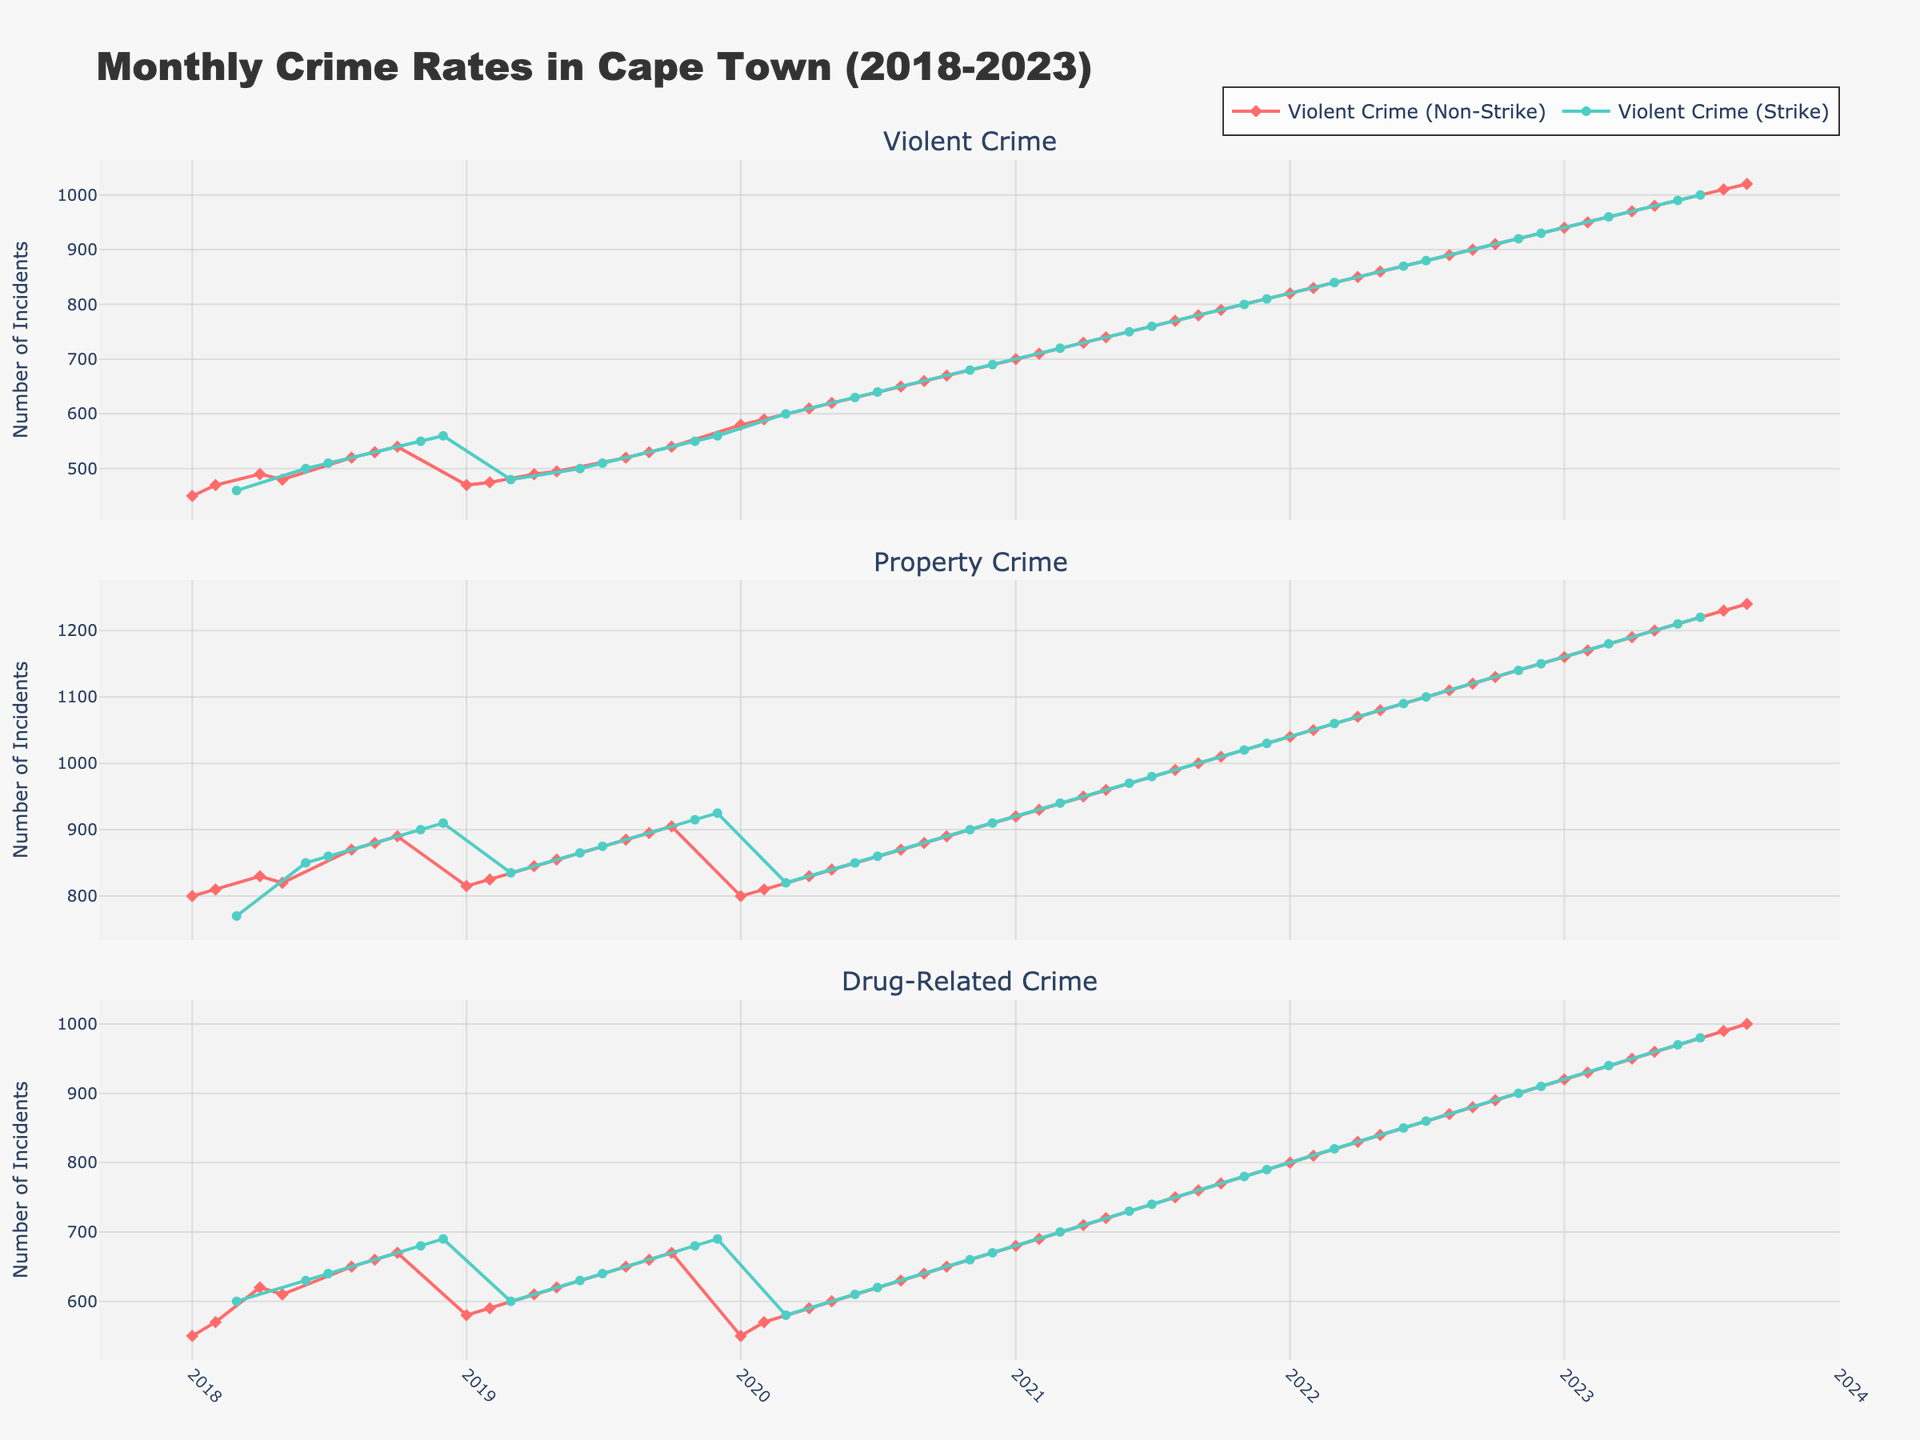How does the violent crime rate during strike periods compare to non-strike periods? To compare, look at the violent crime trend lines for periods marked as "Strike" and "Non-Strike," identified by the different colors in the plot. Examine their heights and patterns over time.
Answer: Higher during strikes What is the general trend of property crime over the five years? Observe the property crime line. Assess whether it increases, decreases, or remains constant over the period from 2018 to 2023.
Answer: Increasing Are drug-related crimes more frequent in strike periods or non-strike periods? Compare the heights and markers of drug-related crime lines for periods labeled as 'Yes' and 'No'. The frequency can be inferred from higher values.
Answer: More frequent in non-strike periods Which year had the highest peak in violent crime? Find the highest point in the violent crime subplot and match it to the corresponding year on the x-axis below the point.
Answer: 2023 What is the most noticeable difference between strike and non-strike periods for property crimes? Look for variations in the property crime line's behavior during periods marked 'Yes' and 'No'. Note the changes in the pattern or level.
Answer: Non-strike periods generally have lower property crimes Which type of crime shows the least variation between strike and non-strike periods? Assess the variation in plot lines between strike and non-strike periods for each crime type. The one with the smallest difference is the answer.
Answer: Property Crime By how much did violent crime increase from January 2018 to September 2023? Identify violent crime values for January 2018 and September 2023. Subtract the earlier figure from the later one to compute the increase.
Answer: 570 How did the drug-related crime rate change during the strikes around mid-2019? Find mid-2019. Observe the drug-related crime values before, during, and after the mid-2019 strike periods. Compare changes in crime rates.
Answer: Modest increase In which months of 2018 were non-strike periods, and how did violent crime rates change in that time? Identify months with 'Yes' for 2018 and examine the corresponding violent crime values. Trace changes over those months.
Answer: January, February, April, May, August, September, October Which year had the lowest drug-related crime rate during a strike period? Identify the lowest point for drug-related crime markers during strike periods on the timeline and match it to its year.
Answer: 2018 